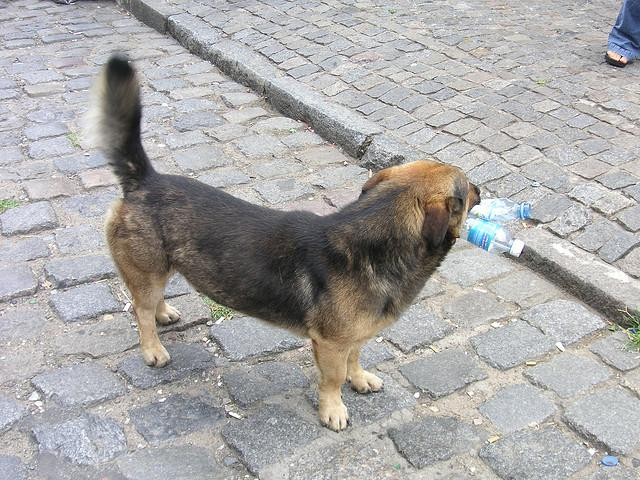What is in the dog's mouth? bottles 